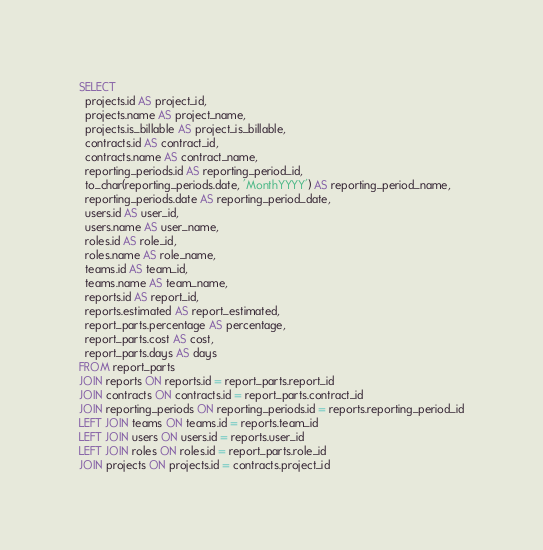Convert code to text. <code><loc_0><loc_0><loc_500><loc_500><_SQL_>SELECT
  projects.id AS project_id,
  projects.name AS project_name,
  projects.is_billable AS project_is_billable,
  contracts.id AS contract_id,
  contracts.name AS contract_name,
  reporting_periods.id AS reporting_period_id,
  to_char(reporting_periods.date, 'MonthYYYY') AS reporting_period_name,
  reporting_periods.date AS reporting_period_date,
  users.id AS user_id,
  users.name AS user_name,
  roles.id AS role_id,
  roles.name AS role_name,
  teams.id AS team_id,
  teams.name AS team_name,
  reports.id AS report_id,
  reports.estimated AS report_estimated,
  report_parts.percentage AS percentage,
  report_parts.cost AS cost,
  report_parts.days AS days
FROM report_parts
JOIN reports ON reports.id = report_parts.report_id
JOIN contracts ON contracts.id = report_parts.contract_id
JOIN reporting_periods ON reporting_periods.id = reports.reporting_period_id
LEFT JOIN teams ON teams.id = reports.team_id
LEFT JOIN users ON users.id = reports.user_id
LEFT JOIN roles ON roles.id = report_parts.role_id
JOIN projects ON projects.id = contracts.project_id

</code> 